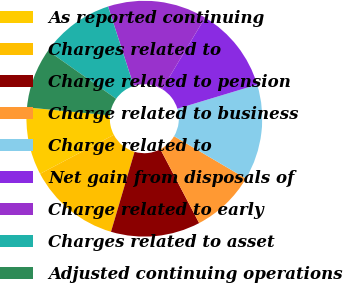Convert chart to OTSL. <chart><loc_0><loc_0><loc_500><loc_500><pie_chart><fcel>As reported continuing<fcel>Charges related to<fcel>Charge related to pension<fcel>Charge related to business<fcel>Charge related to<fcel>Net gain from disposals of<fcel>Charge related to early<fcel>Charges related to asset<fcel>Adjusted continuing operations<nl><fcel>9.27%<fcel>12.7%<fcel>12.26%<fcel>8.83%<fcel>13.14%<fcel>11.72%<fcel>13.59%<fcel>10.24%<fcel>8.25%<nl></chart> 